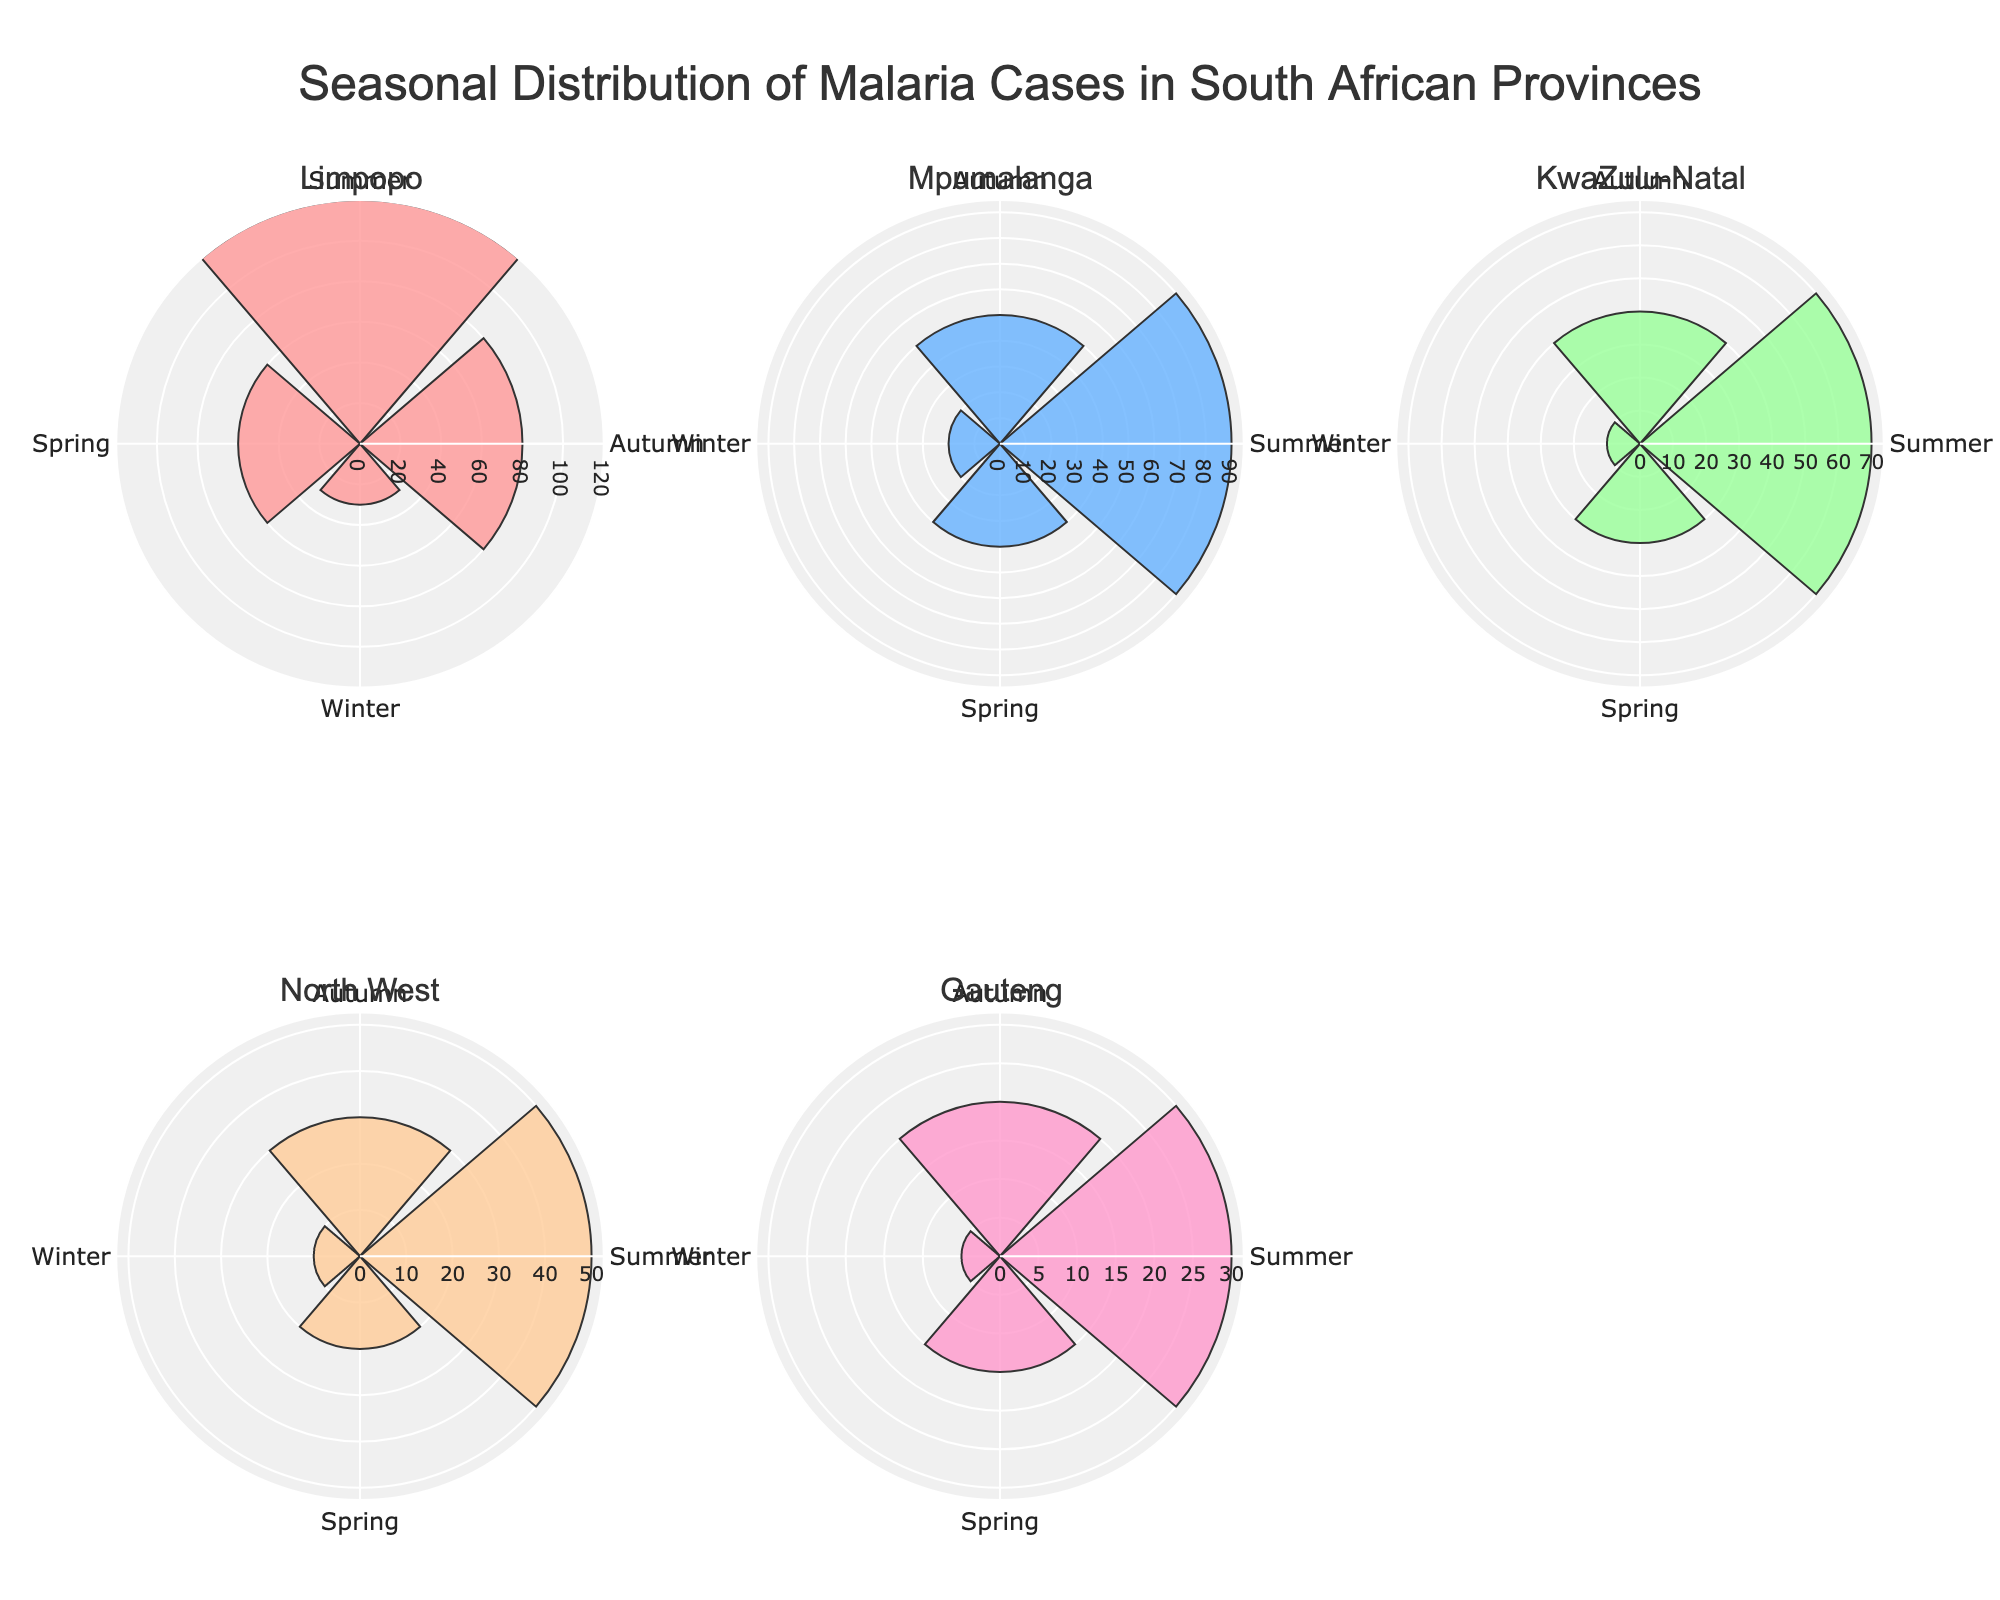What is the title of the figure? The title is located at the top-center of the figure and reads: "Seasonal Distribution of Malaria Cases in South African Provinces"
Answer: Seasonal Distribution of Malaria Cases in South African Provinces Which province has the highest malaria cases in Summer? Identify the segment with the largest radius in the Summer for all provinces. Limpopo has the highest segment extending to 120 cases.
Answer: Limpopo How many malaria cases are reported in Gauteng during Winter? Locate the segment for Winter in the Gauteng subplot and find the corresponding value which is 5.
Answer: 5 Comparing Limpopo and Mpumalanga, which province has more malaria cases in Spring? Find the Spring segments in Limpopo and Mpumalanga. Limpopo has 60 cases while Mpumalanga has 40, so Limpopo has more cases.
Answer: Limpopo What is the sum of malaria cases in Mpumalanga across all seasons? Sum the malaria cases in all four seasons for Mpumalanga: 90 (Summer) + 50 (Autumn) + 20 (Winter) + 40 (Spring) = 200
Answer: 200 Which season generally sees the highest malaria cases across all provinces? Observe the radar (rose) chart's radial extension across all provinces and seasons. Summer segments are the most extended in general, showing higher counts.
Answer: Summer What is the range of malaria cases across all seasons for KwaZulu-Natal? Identify the minimum and maximum cases in KwaZulu-Natal across the seasons. They range from 10 (Winter) to 70 (Summer), so the range is 70 - 10 = 60.
Answer: 60 Which province shows the least variation in malaria cases across seasons? Assess the consistency of the segment lengths across seasons for each province. Gauteng shows the least variation (5 to 30), while others show larger variations.
Answer: Gauteng Between North West and KwaZulu-Natal, which province has fewer malaria cases in Autumn? Compare the Autumn segments. North West has 30 cases, while KwaZulu-Natal has 40. Therefore, North West has fewer cases.
Answer: North West What is the average number of malaria cases in Spring for all provinces combined? Sum the Spring cases: 60 (Limpopo) + 40 (Mpumalanga) + 30 (KwaZulu-Natal) + 20 (North West) + 15 (Gauteng) = 165. There are 5 provinces, so average is 165/5 = 33
Answer: 33 